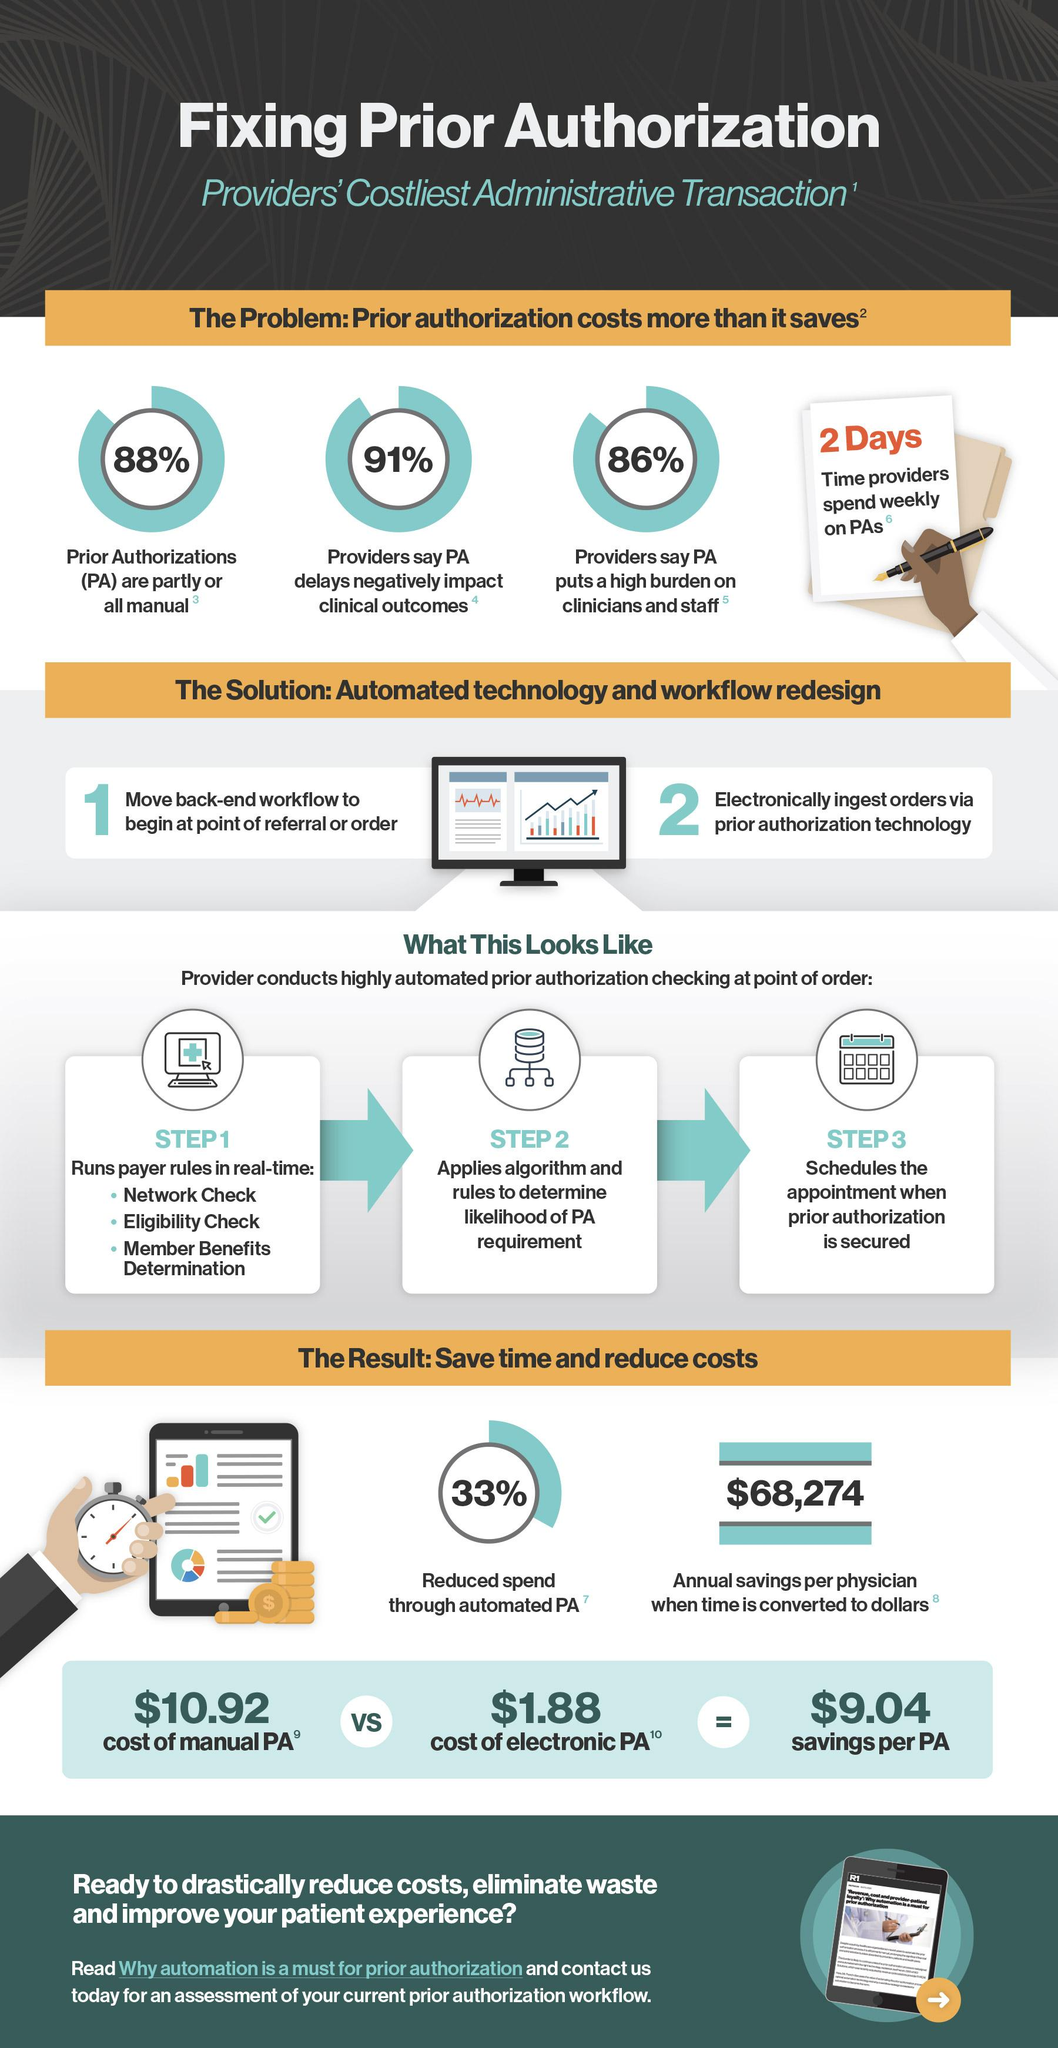Give some essential details in this illustration. On average, time providers spend two days per week on processing patient authorizations (PAs). Shifting from a manual personnel administration (PA) to an electronic PA could result in savings of $9.04. The annual savings per physician when time is converted to dollars is $68,274. In the Pacific Autonomous Region, 88% of the population is served by manual or partially manual systems. 